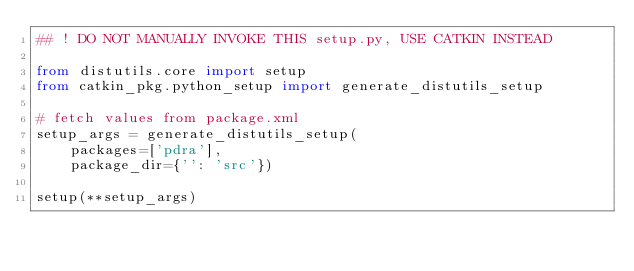Convert code to text. <code><loc_0><loc_0><loc_500><loc_500><_Python_>## ! DO NOT MANUALLY INVOKE THIS setup.py, USE CATKIN INSTEAD

from distutils.core import setup
from catkin_pkg.python_setup import generate_distutils_setup

# fetch values from package.xml
setup_args = generate_distutils_setup(
    packages=['pdra'],
    package_dir={'': 'src'})

setup(**setup_args)
</code> 